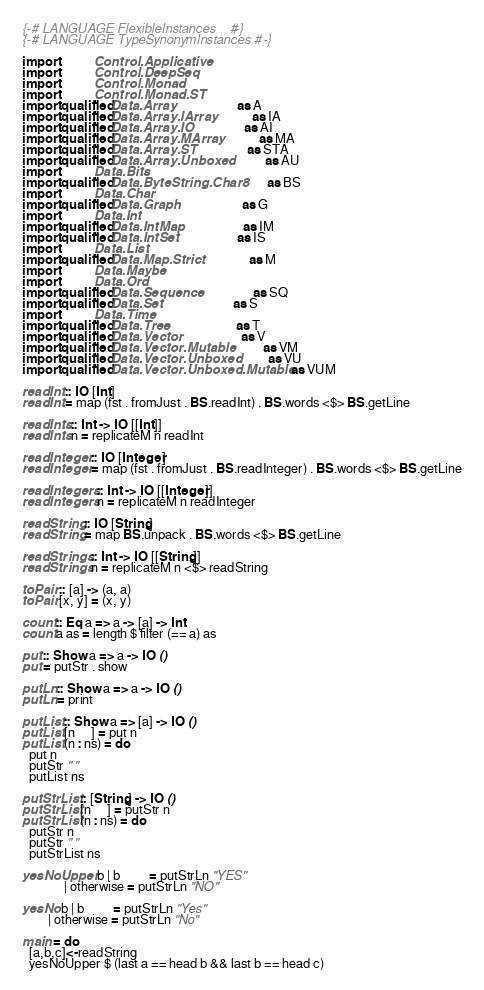<code> <loc_0><loc_0><loc_500><loc_500><_Haskell_>{-# LANGUAGE FlexibleInstances    #-}
{-# LANGUAGE TypeSynonymInstances #-}

import           Control.Applicative
import           Control.DeepSeq
import           Control.Monad
import           Control.Monad.ST
import qualified Data.Array                    as A
import qualified Data.Array.IArray             as IA
import qualified Data.Array.IO                 as AI
import qualified Data.Array.MArray             as MA
import qualified Data.Array.ST                 as STA
import qualified Data.Array.Unboxed            as AU
import           Data.Bits
import qualified Data.ByteString.Char8         as BS
import           Data.Char
import qualified Data.Graph                    as G
import           Data.Int
import qualified Data.IntMap                   as IM
import qualified Data.IntSet                   as IS
import           Data.List
import qualified Data.Map.Strict               as M
import           Data.Maybe
import           Data.Ord
import qualified Data.Sequence                 as SQ
import qualified Data.Set                      as S
import           Data.Time
import qualified Data.Tree                     as T
import qualified Data.Vector                   as V
import qualified Data.Vector.Mutable           as VM
import qualified Data.Vector.Unboxed           as VU
import qualified Data.Vector.Unboxed.Mutable   as VUM

readInt :: IO [Int]
readInt = map (fst . fromJust . BS.readInt) . BS.words <$> BS.getLine

readInts :: Int -> IO [[Int]]
readInts n = replicateM n readInt

readInteger :: IO [Integer]
readInteger = map (fst . fromJust . BS.readInteger) . BS.words <$> BS.getLine

readIntegers :: Int -> IO [[Integer]]
readIntegers n = replicateM n readInteger

readString :: IO [String]
readString = map BS.unpack . BS.words <$> BS.getLine

readStrings :: Int -> IO [[String]]
readStrings n = replicateM n <$> readString

toPair :: [a] -> (a, a)
toPair [x, y] = (x, y)

count :: Eq a => a -> [a] -> Int
count a as = length $ filter (== a) as

put :: Show a => a -> IO ()
put = putStr . show

putLn :: Show a => a -> IO ()
putLn = print

putList :: Show a => [a] -> IO ()
putList [n     ] = put n
putList (n : ns) = do
  put n
  putStr " "
  putList ns

putStrList :: [String] -> IO ()
putStrList [n     ] = putStr n
putStrList (n : ns) = do
  putStr n
  putStr " "
  putStrList ns

yesNoUpper b | b         = putStrLn "YES"
             | otherwise = putStrLn "NO"

yesNo b | b         = putStrLn "Yes"
        | otherwise = putStrLn "No"

main = do
  [a,b,c]<-readString
  yesNoUpper $ (last a == head b && last b == head c)</code> 